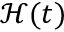<formula> <loc_0><loc_0><loc_500><loc_500>\mathcal { H } ( t )</formula> 